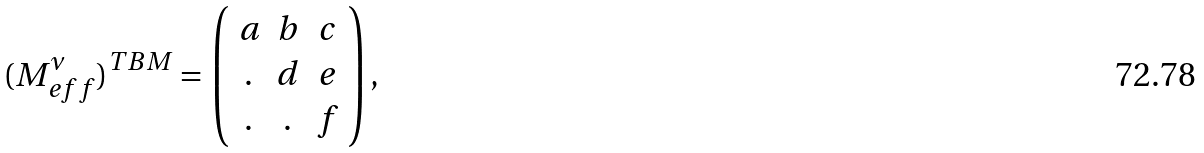<formula> <loc_0><loc_0><loc_500><loc_500>( { M ^ { \nu } _ { e f f } } ) ^ { T B M } = \left ( \begin{array} { c c c } a & b & c \\ . & d & e \\ . & . & f \end{array} \right ) ,</formula> 